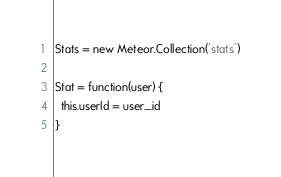<code> <loc_0><loc_0><loc_500><loc_500><_JavaScript_>Stats = new Meteor.Collection('stats')

Stat = function(user) {
  this.userId = user._id
}
</code> 